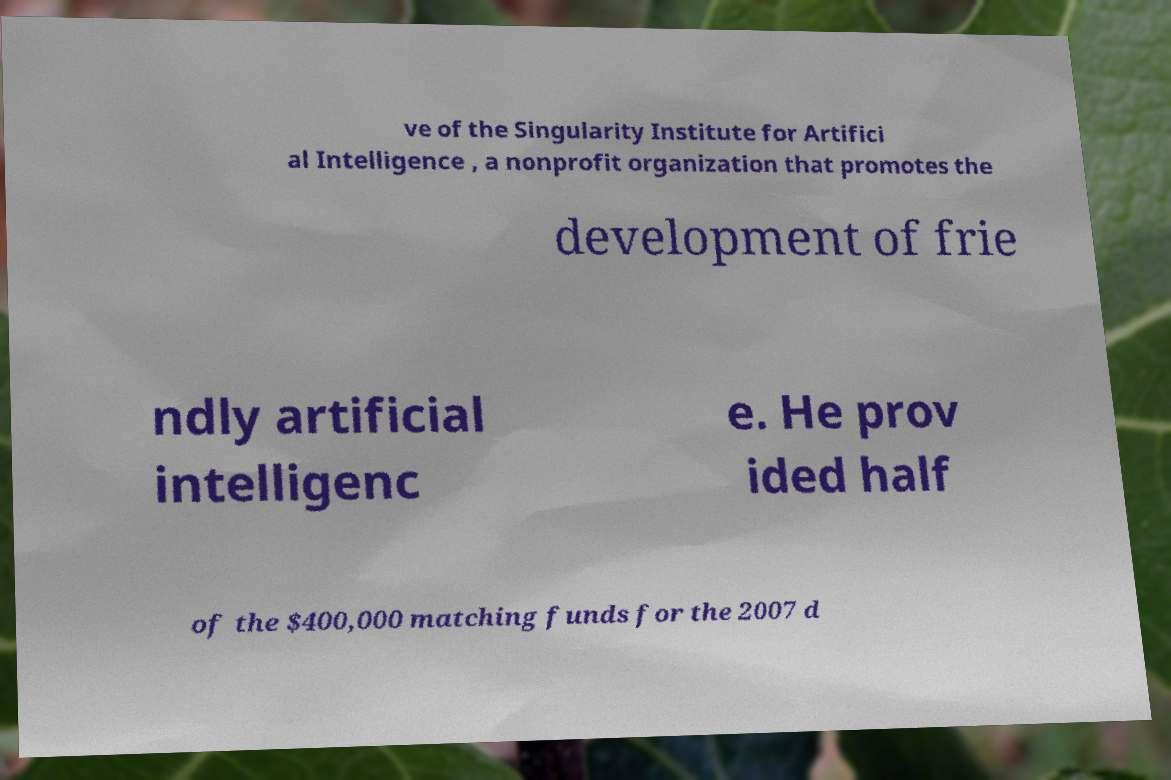Can you accurately transcribe the text from the provided image for me? ve of the Singularity Institute for Artifici al Intelligence , a nonprofit organization that promotes the development of frie ndly artificial intelligenc e. He prov ided half of the $400,000 matching funds for the 2007 d 